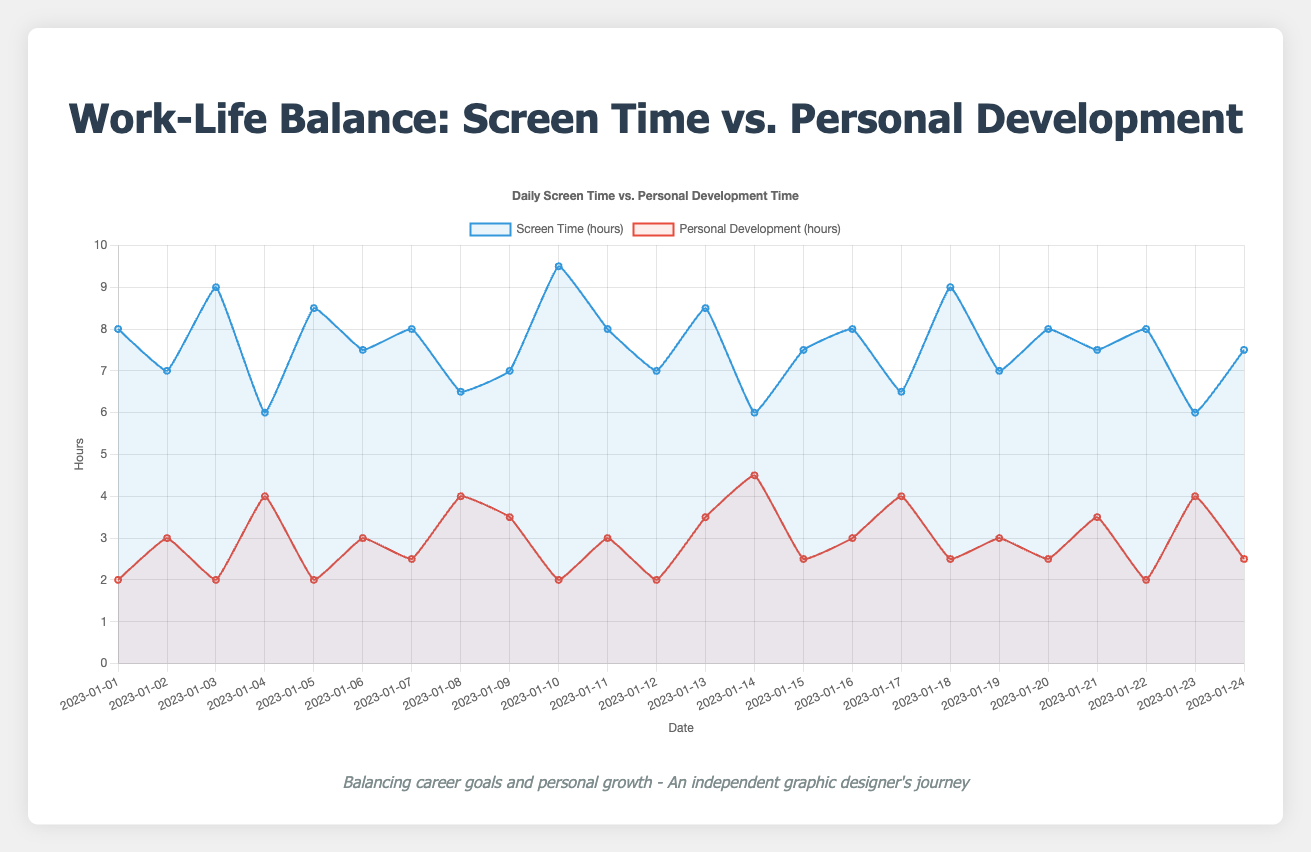What's the total screen time and personal development time on January 05, 2023? On January 05, 2023, the screen time is 8.5 hours, and the personal development time is 2 hours. The total time is 8.5 + 2 = 10.5 hours.
Answer: 10.5 hours Which day has the highest screen time, and how many hours was it? By looking at the peaks in the blue line, we find the highest screen time on January 10, 2023. The value is 9.5 hours.
Answer: January 10, 2023, 9.5 hours How does the screen time on January 14, 2023, compare to the personal development time on the same day? On January 14, 2023, the screen time is 6 hours, and the personal development time is 4.5 hours. Comparing 6 and 4.5, the screen time is 1.5 hours higher.
Answer: Screen time is 1.5 hours higher What's the average daily screen time over the entire period? Sum all the screen time values and divide by the number of days. Total screen time is 8 + 7 + 9 + 6 + 8.5 + 7.5 + 8 + 6.5 + 7 + 9.5 + 8 + 7 + 8.5 + 6 + 7.5 + 8 + 6.5 + 9 + 7 + 8 + 7.5 + 8 + 6 + 7.5 = 179.5 hours. Number of days = 24. Average is 179.5 / 24 ≈ 7.48 hours.
Answer: 7.48 hours Compare the visual trends between screen time and personal development time. Which appears more stable, and how can you tell? The blue line representing screen time fluctuates more with notable peaks and dips compared to the red line representing personal development time that remains relatively more stable. This can be inferred from the visual smoothness and regularity of the lines.
Answer: Personal development time is more stable What is the range of personal development time throughout the period? The highest personal development time is 4.5 hours (on January 14, 2023), and the lowest is 2 hours (on several days). The range is 4.5 - 2 = 2.5 hours.
Answer: 2.5 hours On how many days did the personal development time exceed 3 hours? Reviewing the red line, personal development time exceeds 3 hours on January 04, January 08, January 09, January 13, January 14, January 17, January 21, and January 23. There are 8 such days.
Answer: 8 days Is there any day where screen time and personal development time are equal? By comparing the blue and red lines for all days, there is no day where screen time and personal development time are equal.
Answer: No What's the total personal development time over the period of study? Sum all the personal development time values. Total is 2 + 3 + 2 + 4 + 2 + 3 + 2.5 + 4 + 3.5 + 2 + 3 + 2 + 3.5 + 4.5 + 2.5 + 3 + 4 + 2.5 + 3 + 2.5 + 3.5 + 2 + 4 + 2.5 = 71 hours.
Answer: 71 hours What's the screen time on January 10, 2023, and how does it compare to screen time on January 04, 2023? On January 10, 2023, the screen time is 9.5 hours. On January 04, 2023, the screen time is 6 hours. The screen time on January 10 exceeds that of January 04 by 9.5 - 6 = 3.5 hours.
Answer: 3.5 hours more on January 10, 2023 